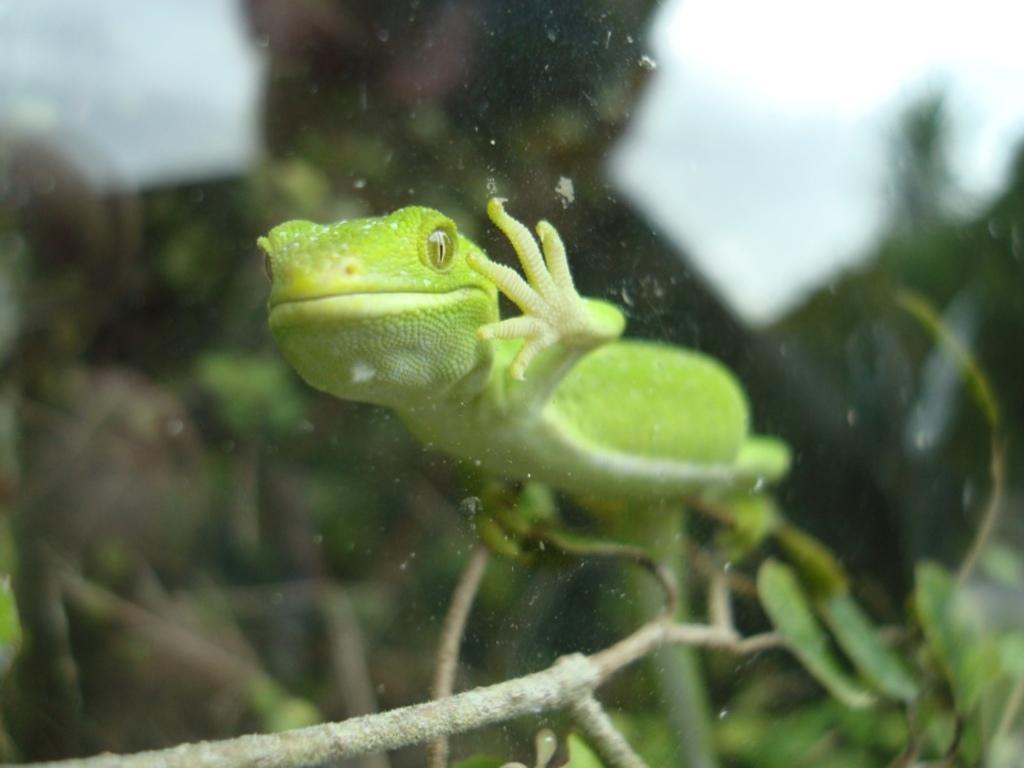In one or two sentences, can you explain what this image depicts? In this image we can see an animal on a plant. 